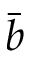Convert formula to latex. <formula><loc_0><loc_0><loc_500><loc_500>\bar { b }</formula> 